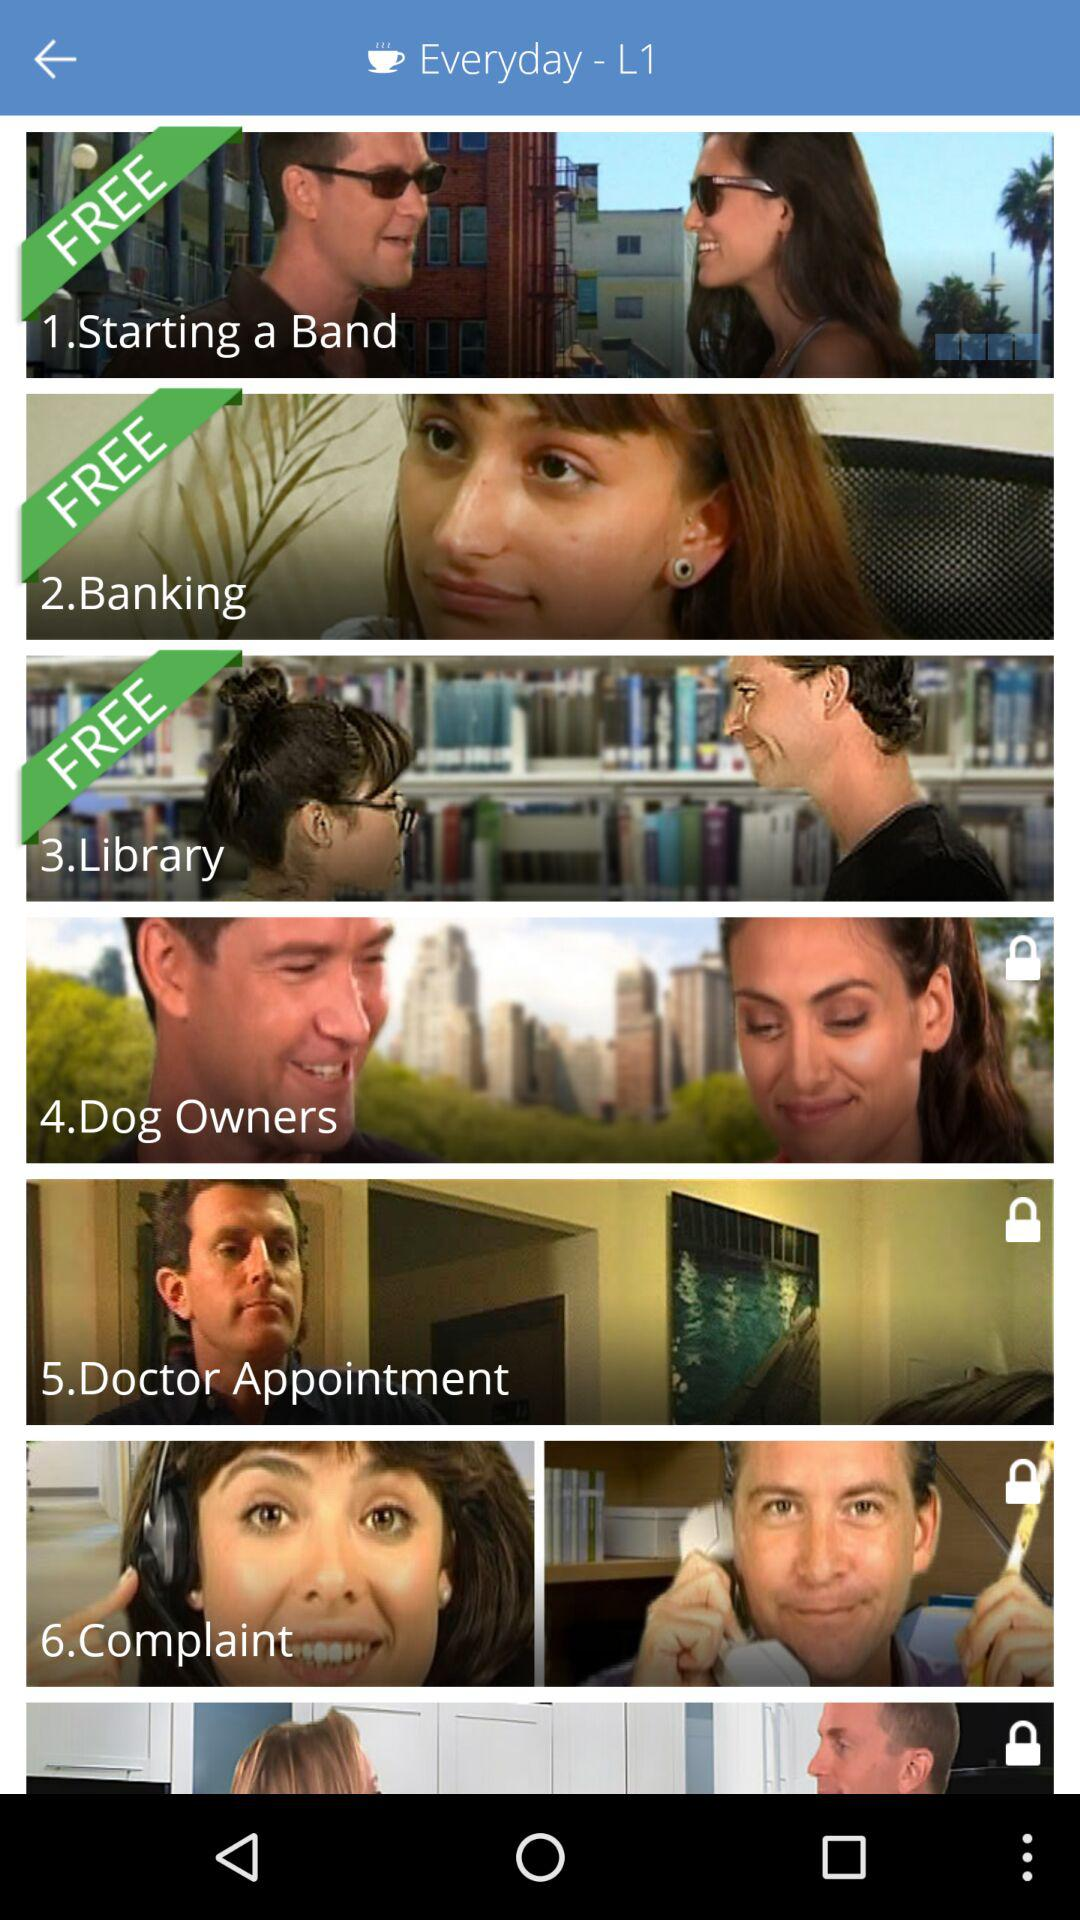Which options are free? The free options are "Starting a Band", "Banking" and "Library". 